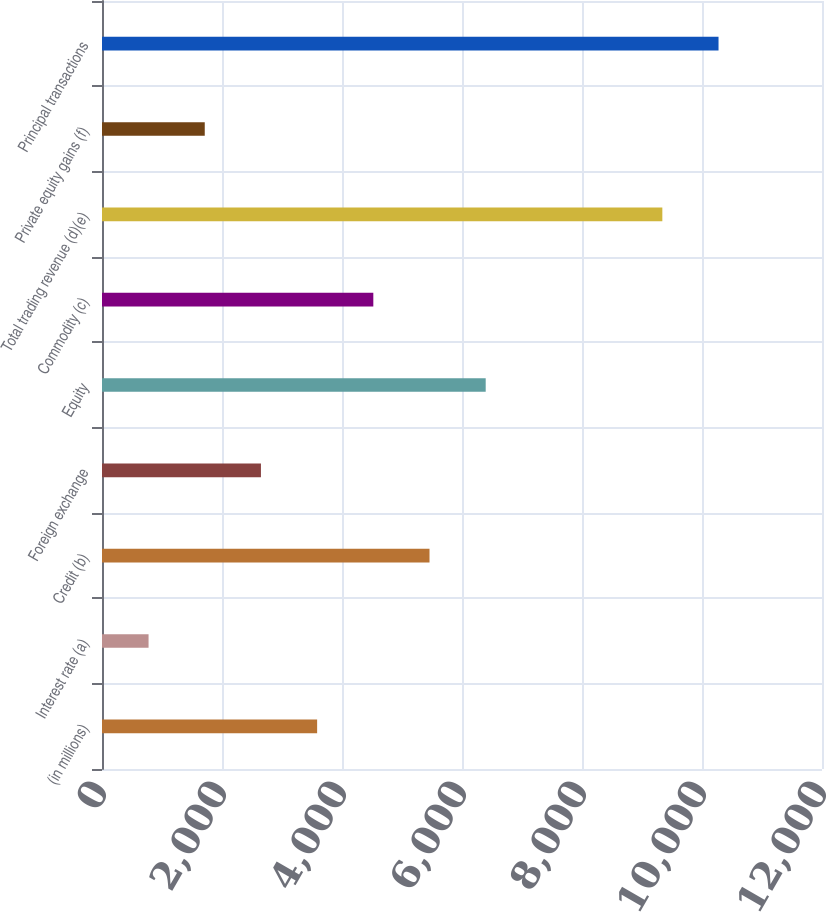Convert chart. <chart><loc_0><loc_0><loc_500><loc_500><bar_chart><fcel>(in millions)<fcel>Interest rate (a)<fcel>Credit (b)<fcel>Foreign exchange<fcel>Equity<fcel>Commodity (c)<fcel>Total trading revenue (d)(e)<fcel>Private equity gains (f)<fcel>Principal transactions<nl><fcel>3585.5<fcel>776<fcel>5458.5<fcel>2649<fcel>6395<fcel>4522<fcel>9339<fcel>1712.5<fcel>10275.5<nl></chart> 